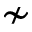<formula> <loc_0><loc_0><loc_500><loc_500>\nsim</formula> 